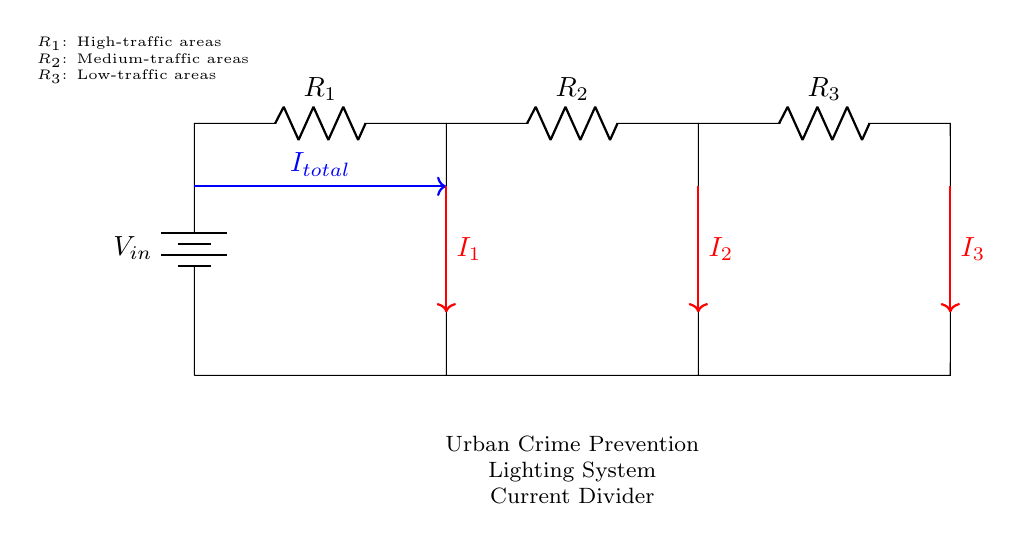What is the total current entering the circuit? The total current, labeled as I total, is the current entering the current divider circuit from the battery, which is illustrated as an arrow pointing towards the resistors.
Answer: I total What components are present in this current divider circuit? The circuit features a voltage source and three resistors, R1, R2, and R3, which are connected in parallel; the voltage source provides the input voltage for the circuit.
Answer: Voltage source, R1, R2, R3 What does R1 represent in this circuit? R1 is specified as representing high-traffic areas in the urban environment, indicating where more intense illumination might be necessary for safety.
Answer: High-traffic areas How do the resistor values affect the current divider's operation? The values of the resistors determine how the total current is split among the branches; lower resistance allows more current to flow through that branch, while higher resistance allows less.
Answer: Current split based on resistance What is the current flowing through R2 if the total current is I total? The current I2 flowing through R2 is proportional to its resistance in relation to the other resistors; specifically, if the value of R2 is known, it can be calculated using the current divider formula.
Answer: Depends on R2 What is the relationship between the branches in a current divider? In a current divider, the sum of the currents through all branches equals the total current entering the circuit, which means I total is the sum of I1, I2, and I3.
Answer: I total = I1 + I2 + I3 Which resistor in this circuit is associated with low-traffic areas? R3 is labeled as the resistor related to low-traffic areas, meaning that it is likely to have less current flowing through it compared to the other resistors.
Answer: R3 